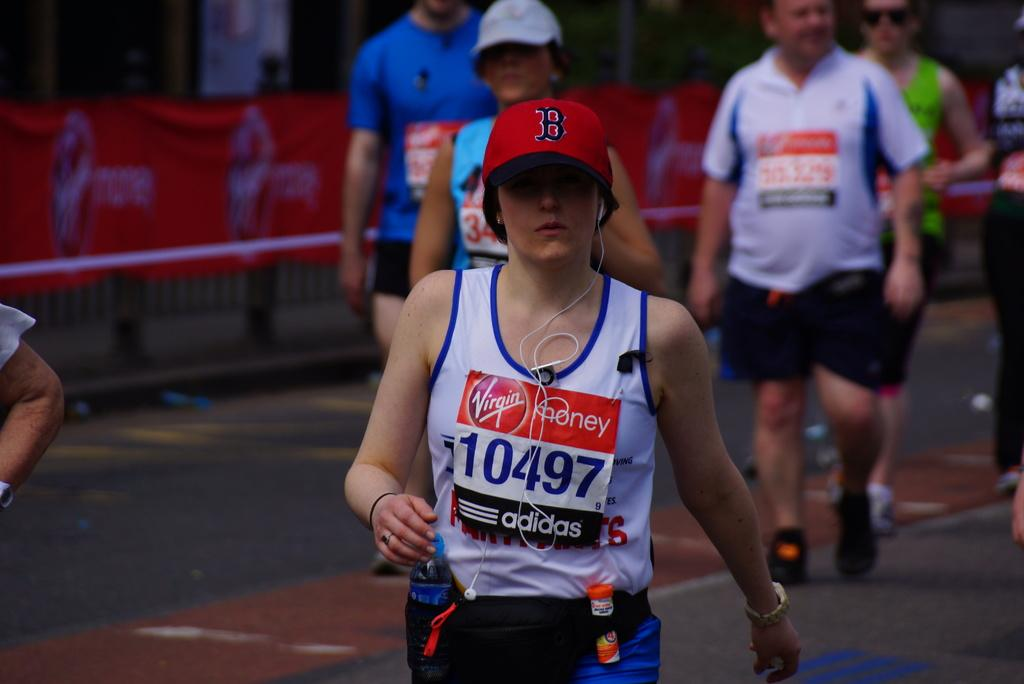<image>
Summarize the visual content of the image. a person walking down the street with the number 10497 on it 